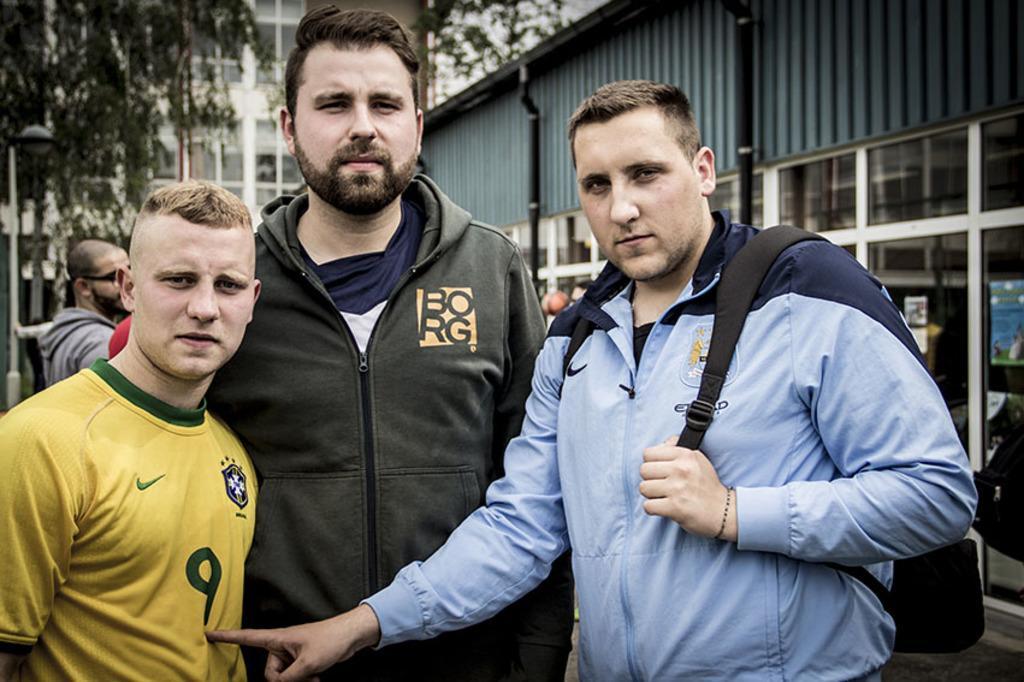How would you summarize this image in a sentence or two? In this image I can see a person wearing yellow colored t shirt, another person wearing black colored jacket and another person's wearing blue colored jacket are standing. In the background I can see a building, few pipes, few trees, a person standing and another building which is white in color. 